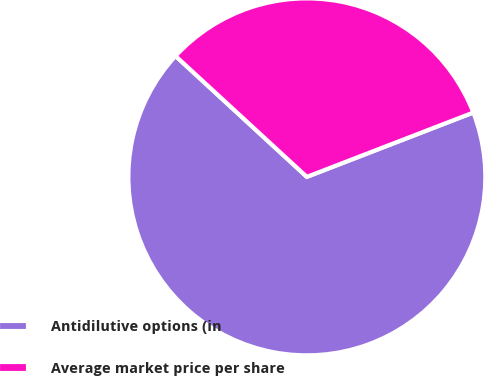Convert chart. <chart><loc_0><loc_0><loc_500><loc_500><pie_chart><fcel>Antidilutive options (in<fcel>Average market price per share<nl><fcel>67.71%<fcel>32.29%<nl></chart> 